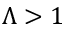Convert formula to latex. <formula><loc_0><loc_0><loc_500><loc_500>\Lambda > 1</formula> 